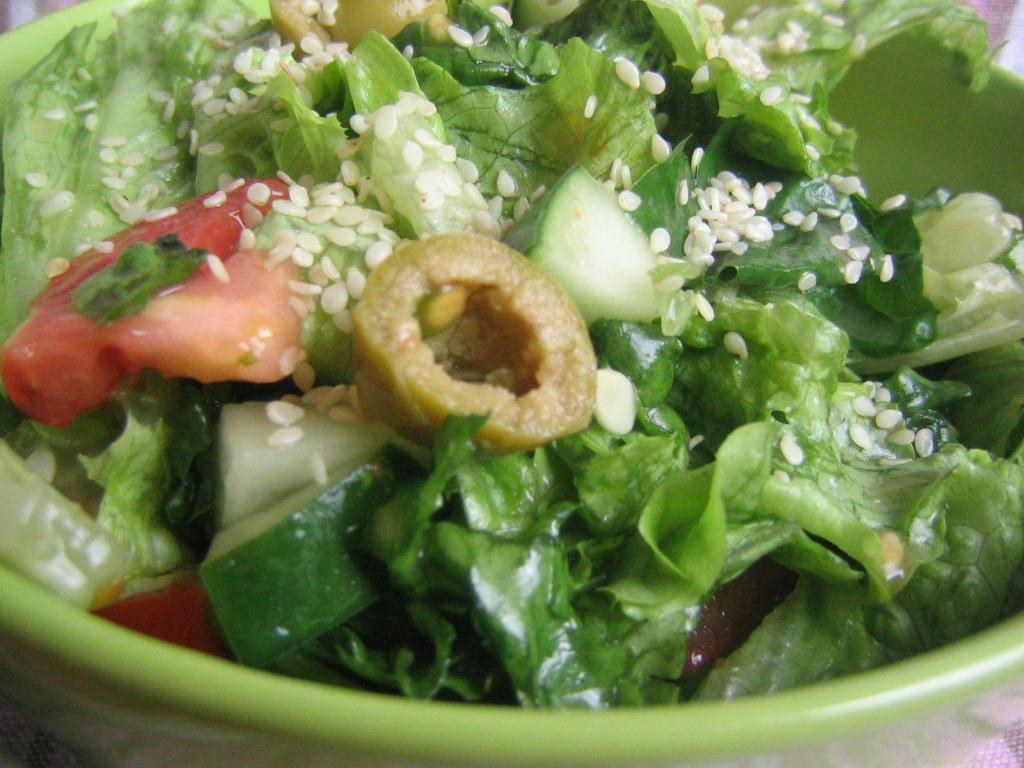What is in the bowl that is visible in the image? The bowl contains salad. What type of food is in the bowl? The bowl contains salad, which is a mixture of vegetables and other ingredients. How many hands are visible in the image? There are no hands visible in the image. Is the salad in the bowl being used as a weapon in the image? No, the salad in the bowl is not being used as a weapon in the image. 